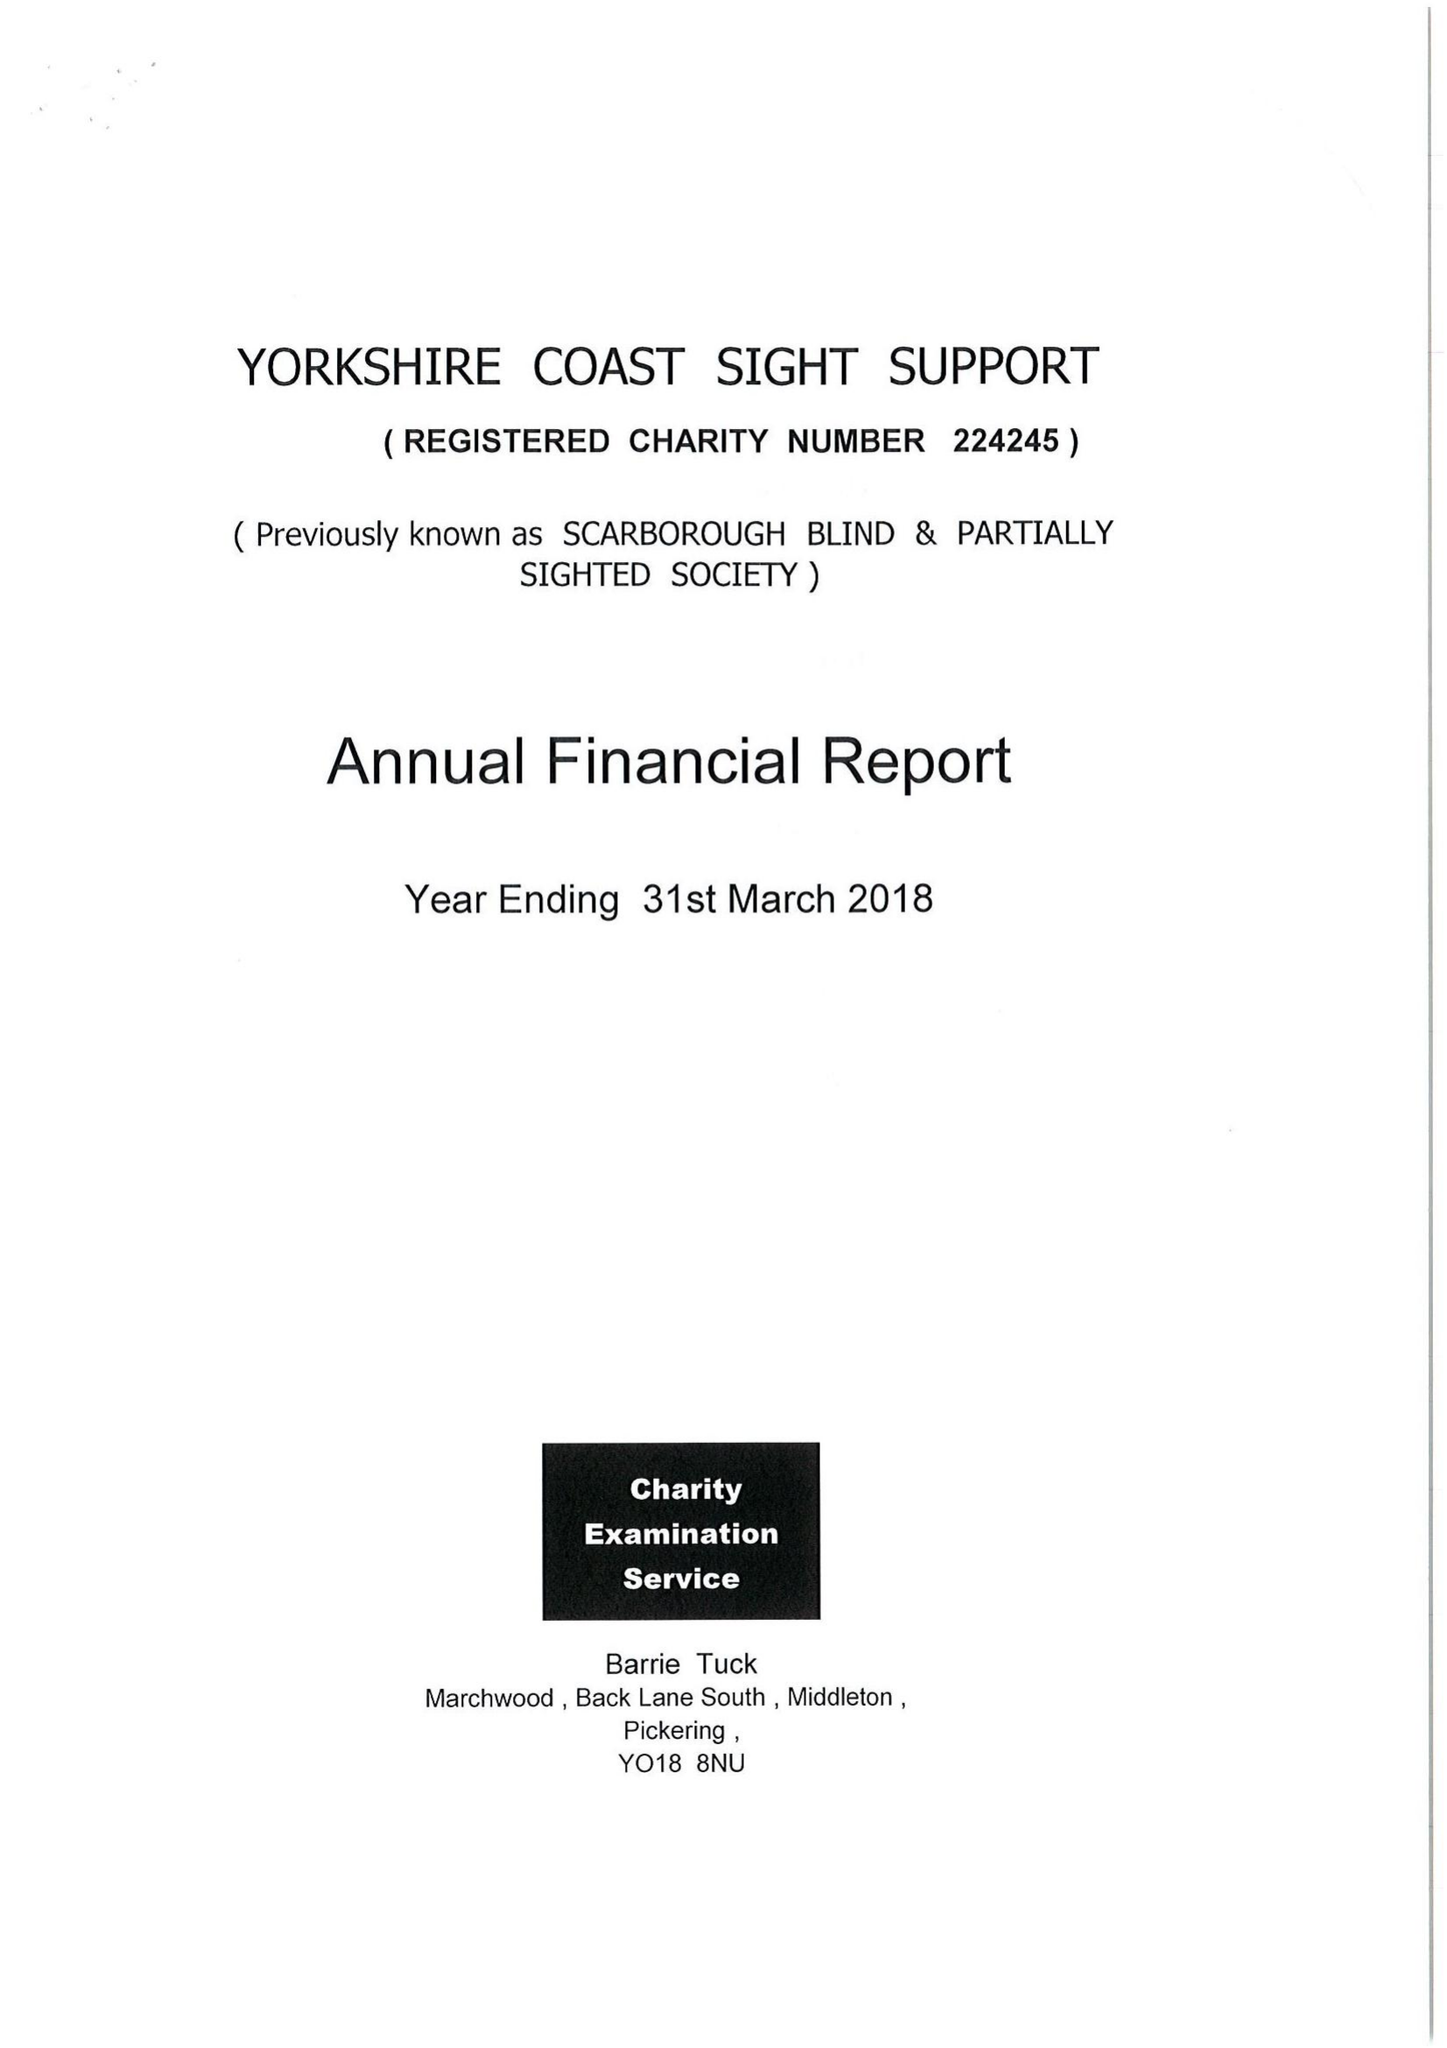What is the value for the address__post_town?
Answer the question using a single word or phrase. SCARBOROUGH 